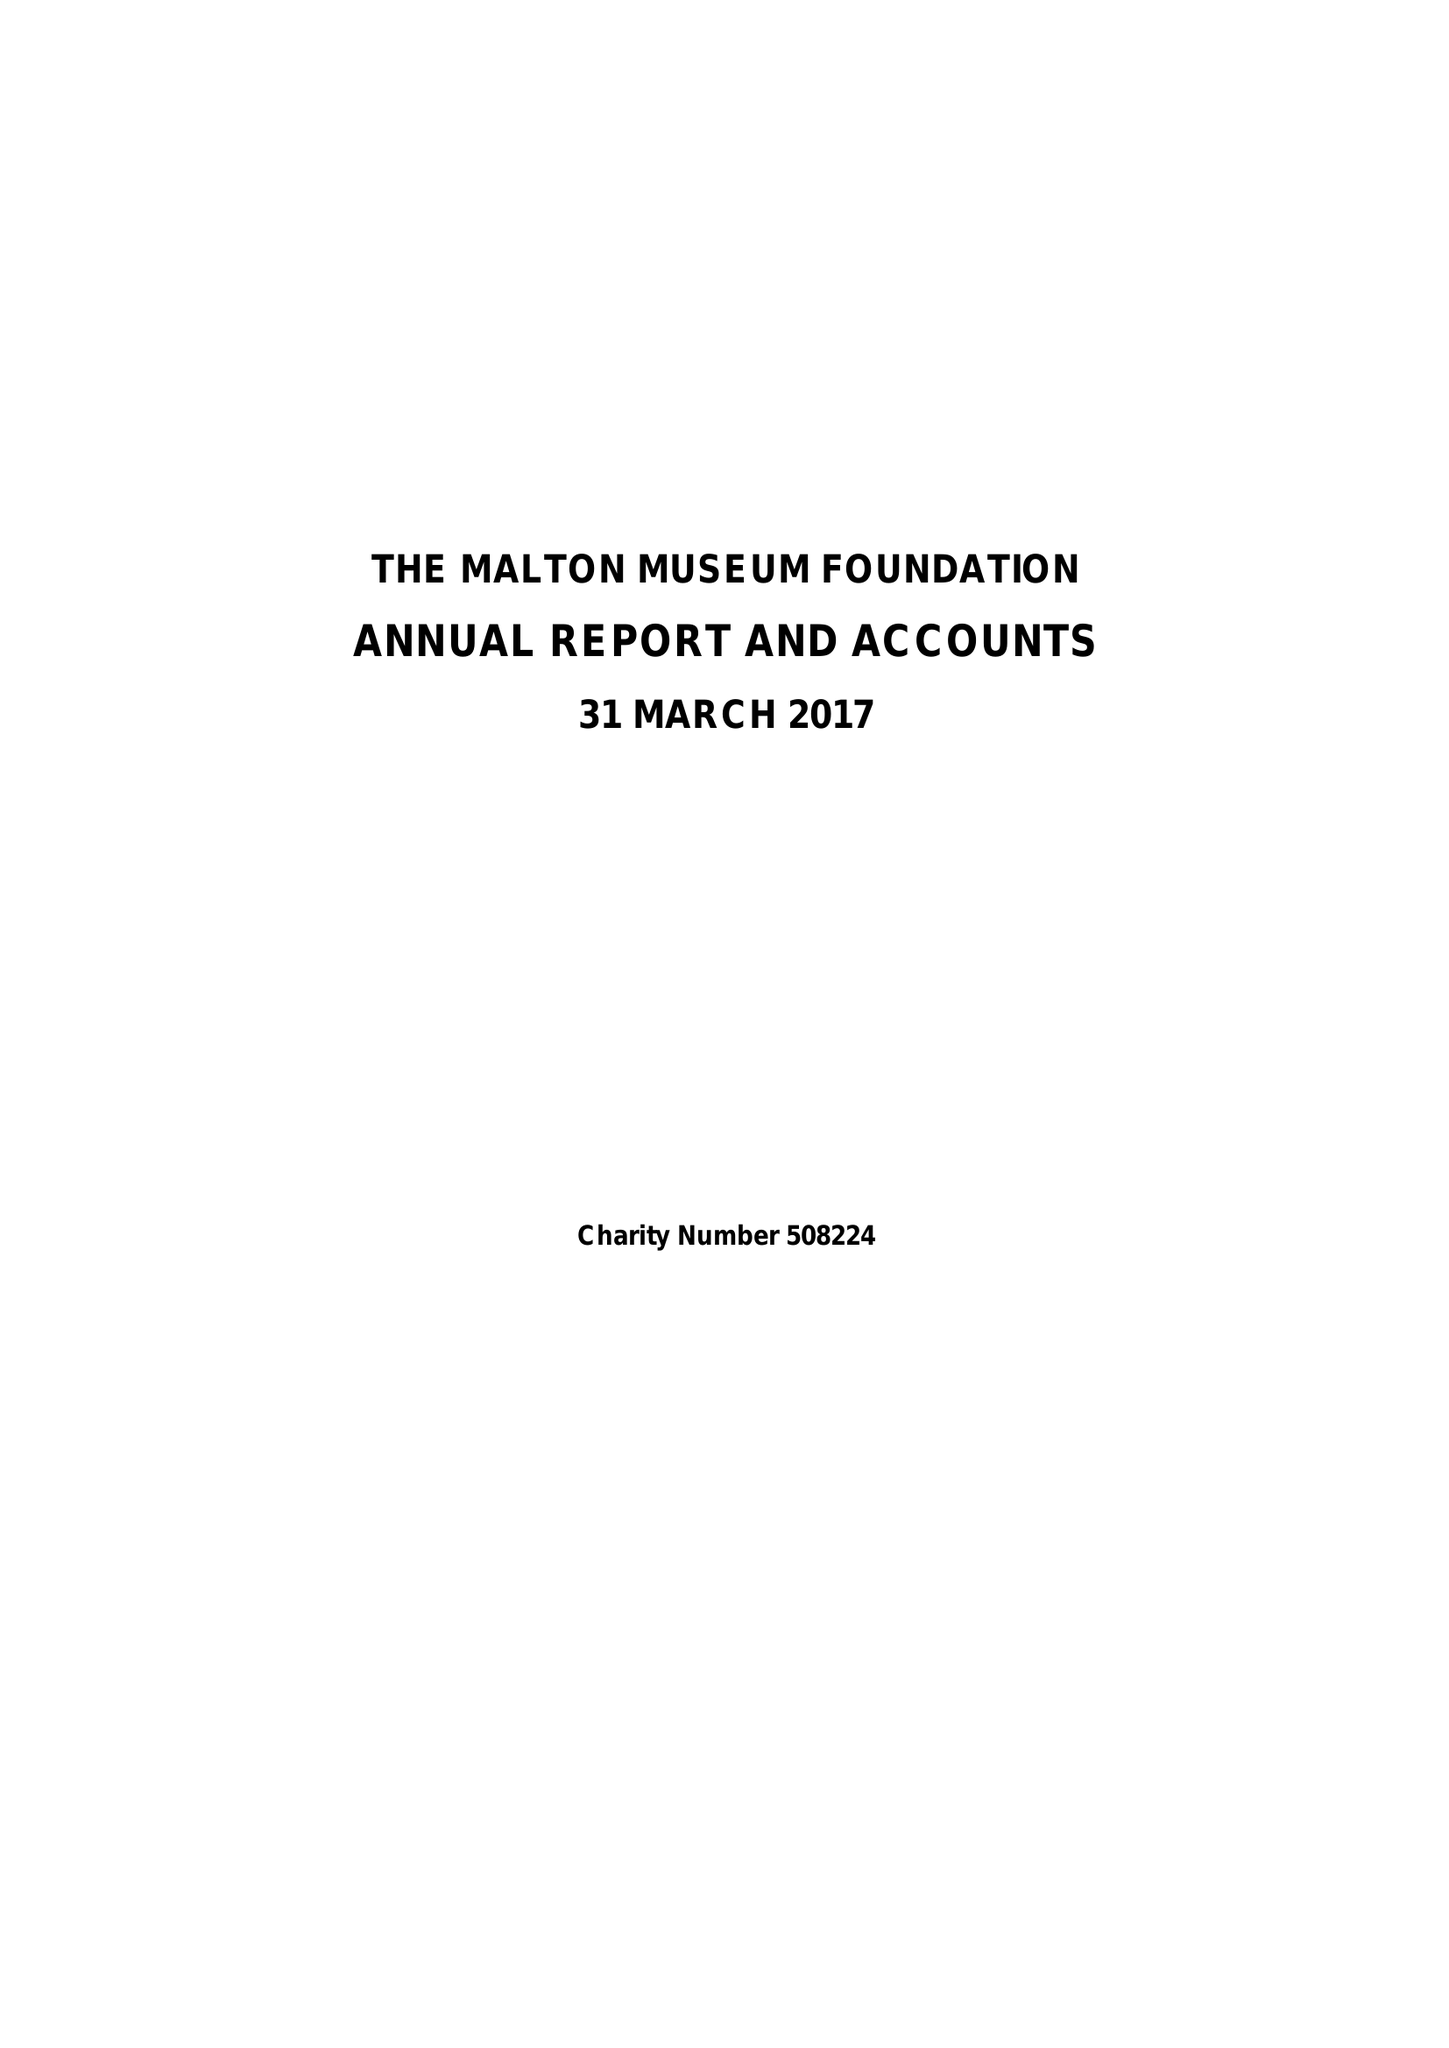What is the value for the charity_name?
Answer the question using a single word or phrase. The Malton Museum Foundation 